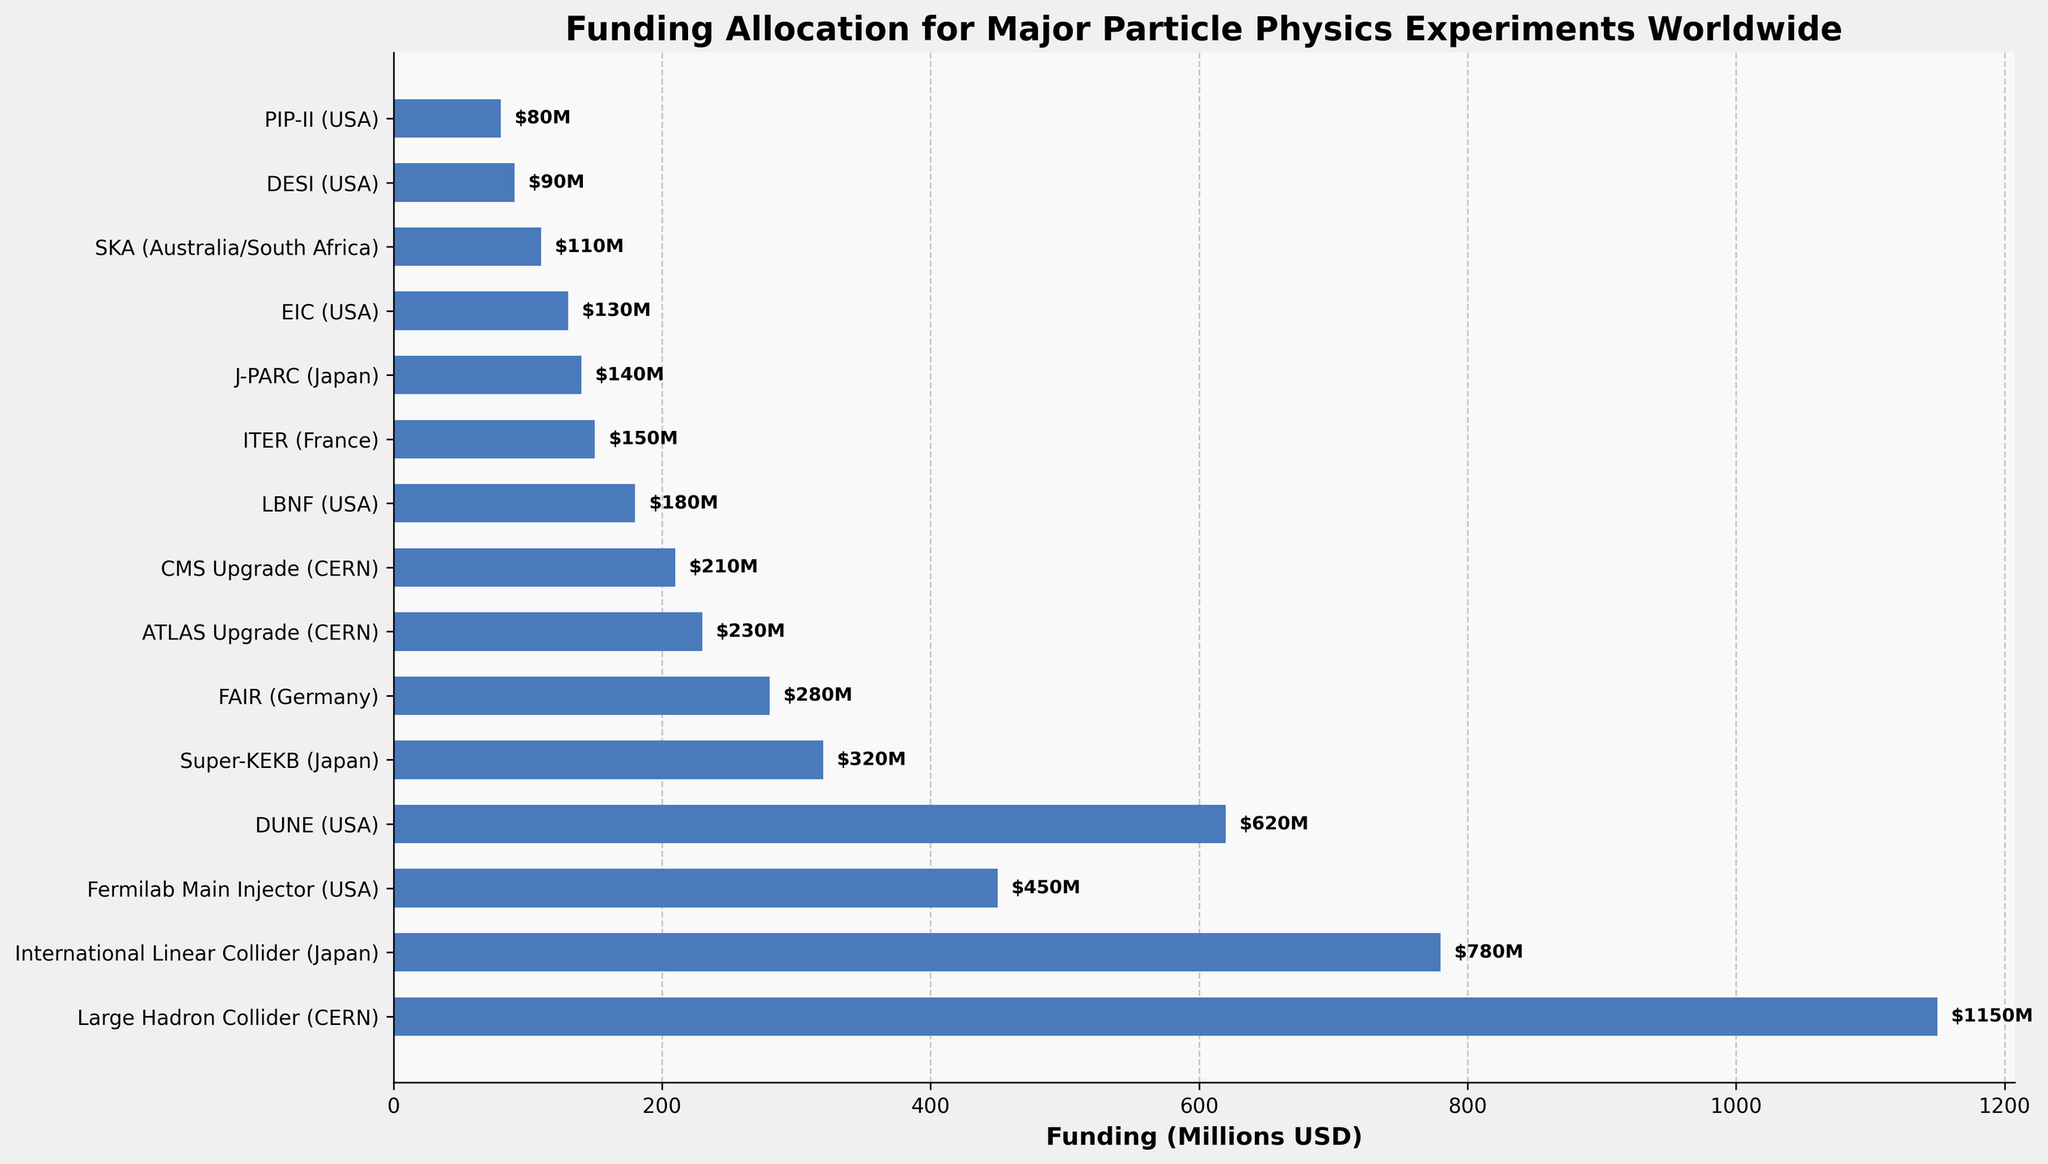what's the total funding for the top three experiments? The top three experiments by funding are the Large Hadron Collider (1150M USD), the International Linear Collider (780M USD), and DUNE (620M USD). Adding these together gives 1150 + 780 + 620 = 2550M USD.
Answer: 2550M USD which experiment has the lowest funding? Looking at the figure, the experiment with the shortest bar represents the lowest funding, which is DESI with 90M USD.
Answer: DESI how much more funding does the Large Hadron Collider receive compared to ITER? The funding for the Large Hadron Collider is 1150M USD and for ITER it is 150M USD. The difference is 1150 - 150 = 1000M USD.
Answer: 1000M USD what is the average funding for experiments based in the USA? The US-based experiments are Fermilab Main Injector (450M USD), DUNE (620M USD), LBNF (180M USD), EIC (130M USD), and DESI (90M USD), and PIP-II (80M USD). Adding these gives a total of 1550M USD, and dividing by the 6 experiments gives 1550/6 = 258.33M USD.
Answer: 258.33M USD how does the funding for Japanese experiments compare to German experiments? The Japanese experiments are International Linear Collider (780M USD), Super-KEKB (320M USD), and J-PARC (140M USD) which sum to 780 + 320 + 140 = 1240M USD. The German experiment FAIR has 280M USD funding. Therefore, Japan's funding (1240M USD) is greater than Germany's funding (280M USD).
Answer: Japan's funding is greater which experiments receive more than 500 million USD in funding? The experiments with bars extending beyond the 500M USD mark include the Large Hadron Collider (1150M USD), International Linear Collider (780M USD), and DUNE (620M USD).
Answer: Large Hadron Collider, International Linear Collider, DUNE what is the median funding amount for all experiments shown? There are 15 experiments, thus the median is the 8th value when ordered. Sorting and finding the 8th value: 80, 90, 110, 130, 140, 150, 180, 210, 230, 280, 320, 450, 620, 780, 1150. The median is 210M USD.
Answer: 210M USD between the Large Hadron Collider and the ATLAS Upgrade, which takes up a larger proportion of the funding allocation? The funding for the Large Hadron Collider is 1150M USD while for the ATLAS Upgrade it's 230M USD. Clearly, the Large Hadron Collider takes up a larger proportion of the total funding allocation.
Answer: Large Hadron Collider how much funding is allocated to experiments at CERN in total? CERN experiments are Large Hadron Collider (1150M USD), ATLAS Upgrade (230M USD), and CMS Upgrade (210M USD). Adding these gives 1150 + 230 + 210 = 1590M USD.
Answer: 1590M USD 